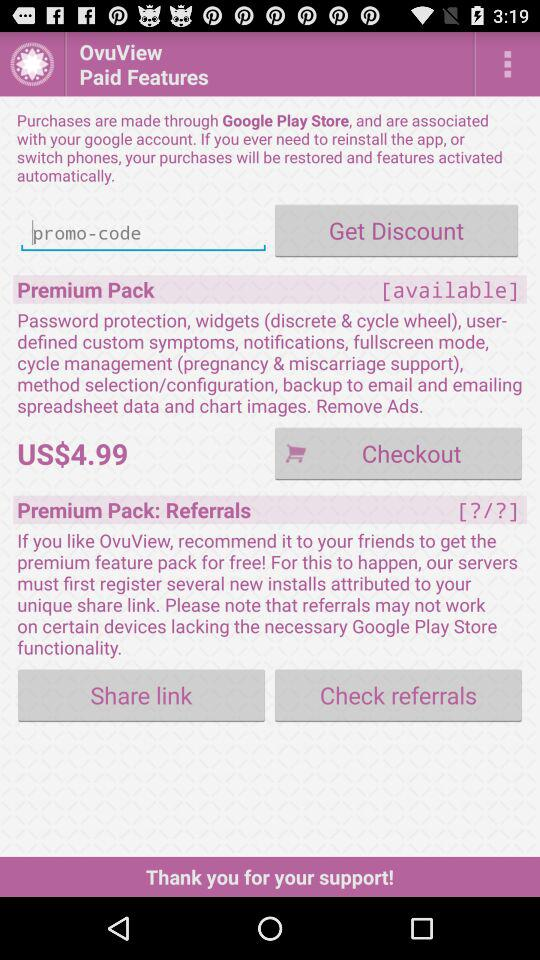What is the name of the application? The name of the application is "OvuView". 